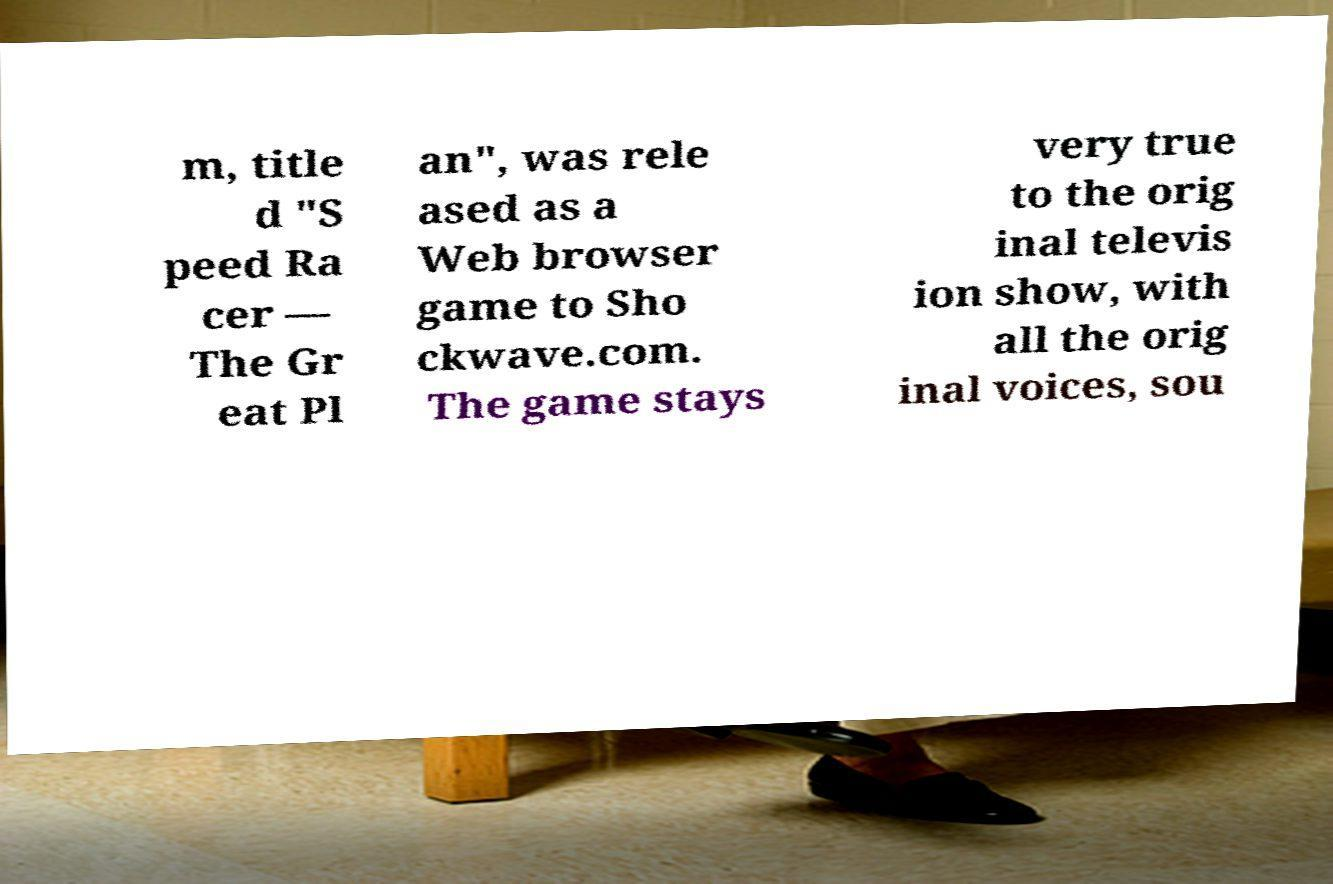There's text embedded in this image that I need extracted. Can you transcribe it verbatim? m, title d "S peed Ra cer — The Gr eat Pl an", was rele ased as a Web browser game to Sho ckwave.com. The game stays very true to the orig inal televis ion show, with all the orig inal voices, sou 